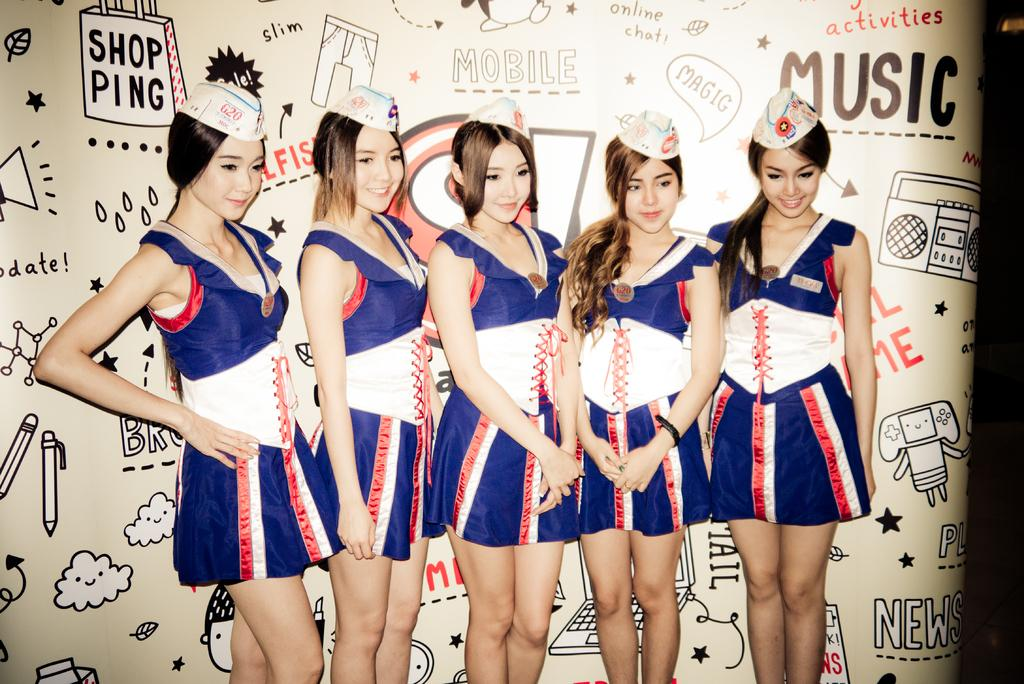Provide a one-sentence caption for the provided image. Five girls in uniform stand in front of a wall with doodles and saying such as 'Music', 'MOBILE', and 'SHOPPING' written on it. 